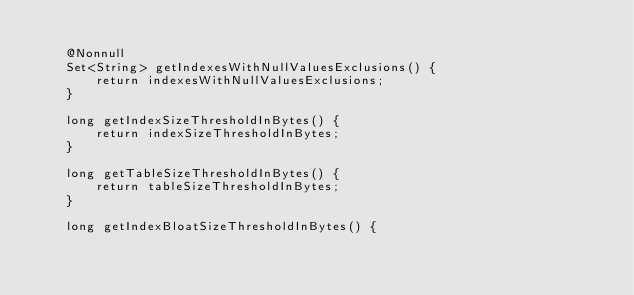Convert code to text. <code><loc_0><loc_0><loc_500><loc_500><_Java_>
    @Nonnull
    Set<String> getIndexesWithNullValuesExclusions() {
        return indexesWithNullValuesExclusions;
    }

    long getIndexSizeThresholdInBytes() {
        return indexSizeThresholdInBytes;
    }

    long getTableSizeThresholdInBytes() {
        return tableSizeThresholdInBytes;
    }

    long getIndexBloatSizeThresholdInBytes() {</code> 